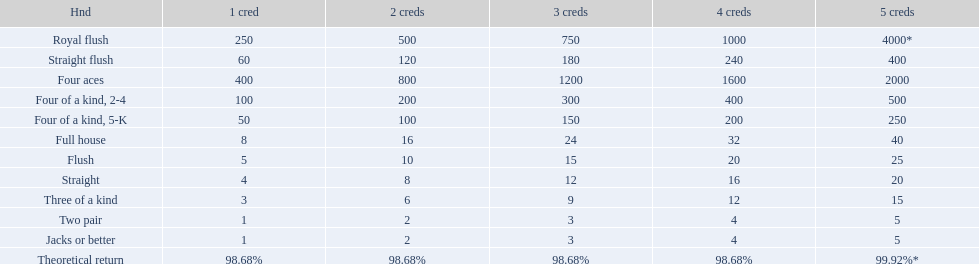Would you be able to parse every entry in this table? {'header': ['Hnd', '1 cred', '2 creds', '3 creds', '4 creds', '5 creds'], 'rows': [['Royal flush', '250', '500', '750', '1000', '4000*'], ['Straight flush', '60', '120', '180', '240', '400'], ['Four aces', '400', '800', '1200', '1600', '2000'], ['Four of a kind, 2-4', '100', '200', '300', '400', '500'], ['Four of a kind, 5-K', '50', '100', '150', '200', '250'], ['Full house', '8', '16', '24', '32', '40'], ['Flush', '5', '10', '15', '20', '25'], ['Straight', '4', '8', '12', '16', '20'], ['Three of a kind', '3', '6', '9', '12', '15'], ['Two pair', '1', '2', '3', '4', '5'], ['Jacks or better', '1', '2', '3', '4', '5'], ['Theoretical return', '98.68%', '98.68%', '98.68%', '98.68%', '99.92%*']]} What are the top 5 best types of hand for winning? Royal flush, Straight flush, Four aces, Four of a kind, 2-4, Four of a kind, 5-K. Between those 5, which of those hands are four of a kind? Four of a kind, 2-4, Four of a kind, 5-K. Of those 2 hands, which is the best kind of four of a kind for winning? Four of a kind, 2-4. 